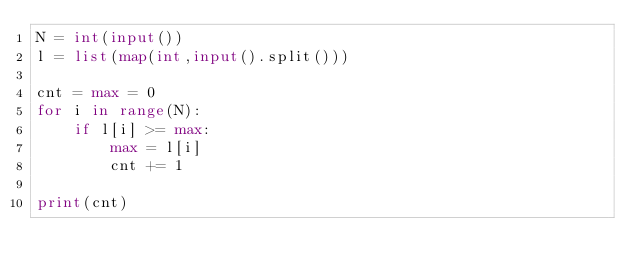<code> <loc_0><loc_0><loc_500><loc_500><_Python_>N = int(input())
l = list(map(int,input().split()))

cnt = max = 0
for i in range(N):
    if l[i] >= max:
        max = l[i]
        cnt += 1

print(cnt)</code> 